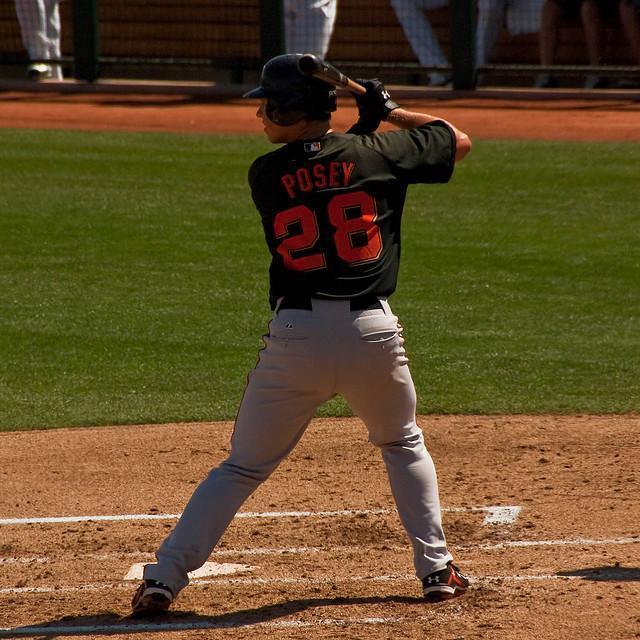How many people are in the photo?
Give a very brief answer. 2. 